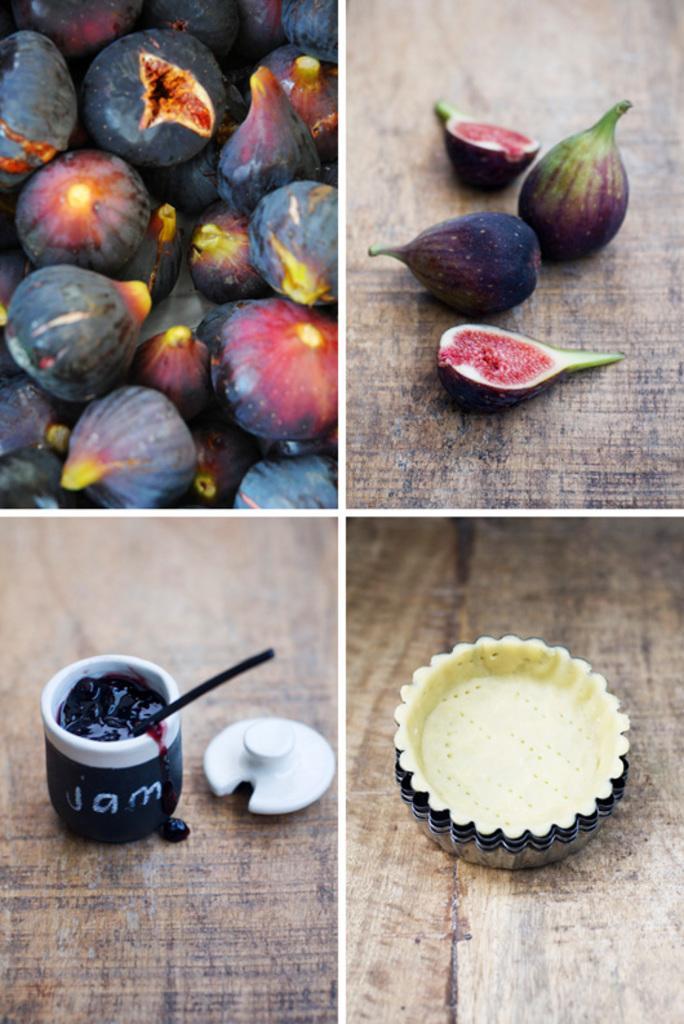Describe this image in one or two sentences. It is a collage image, there are some fruits in the first two pictures, in the third picture there is a jam and in the fourth picture there is a collection of molds. 